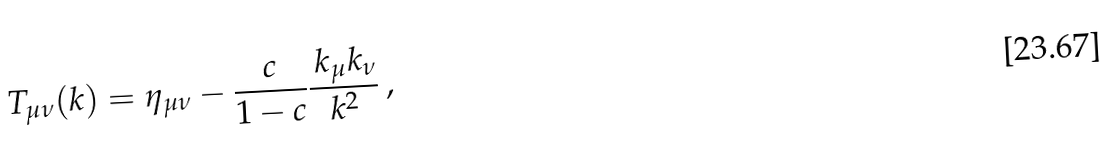Convert formula to latex. <formula><loc_0><loc_0><loc_500><loc_500>T _ { \mu \nu } ( k ) = \eta _ { \mu \nu } - \frac { c } { 1 - c } \frac { \, k _ { \mu } k _ { \nu } } { k ^ { 2 } } \, ,</formula> 